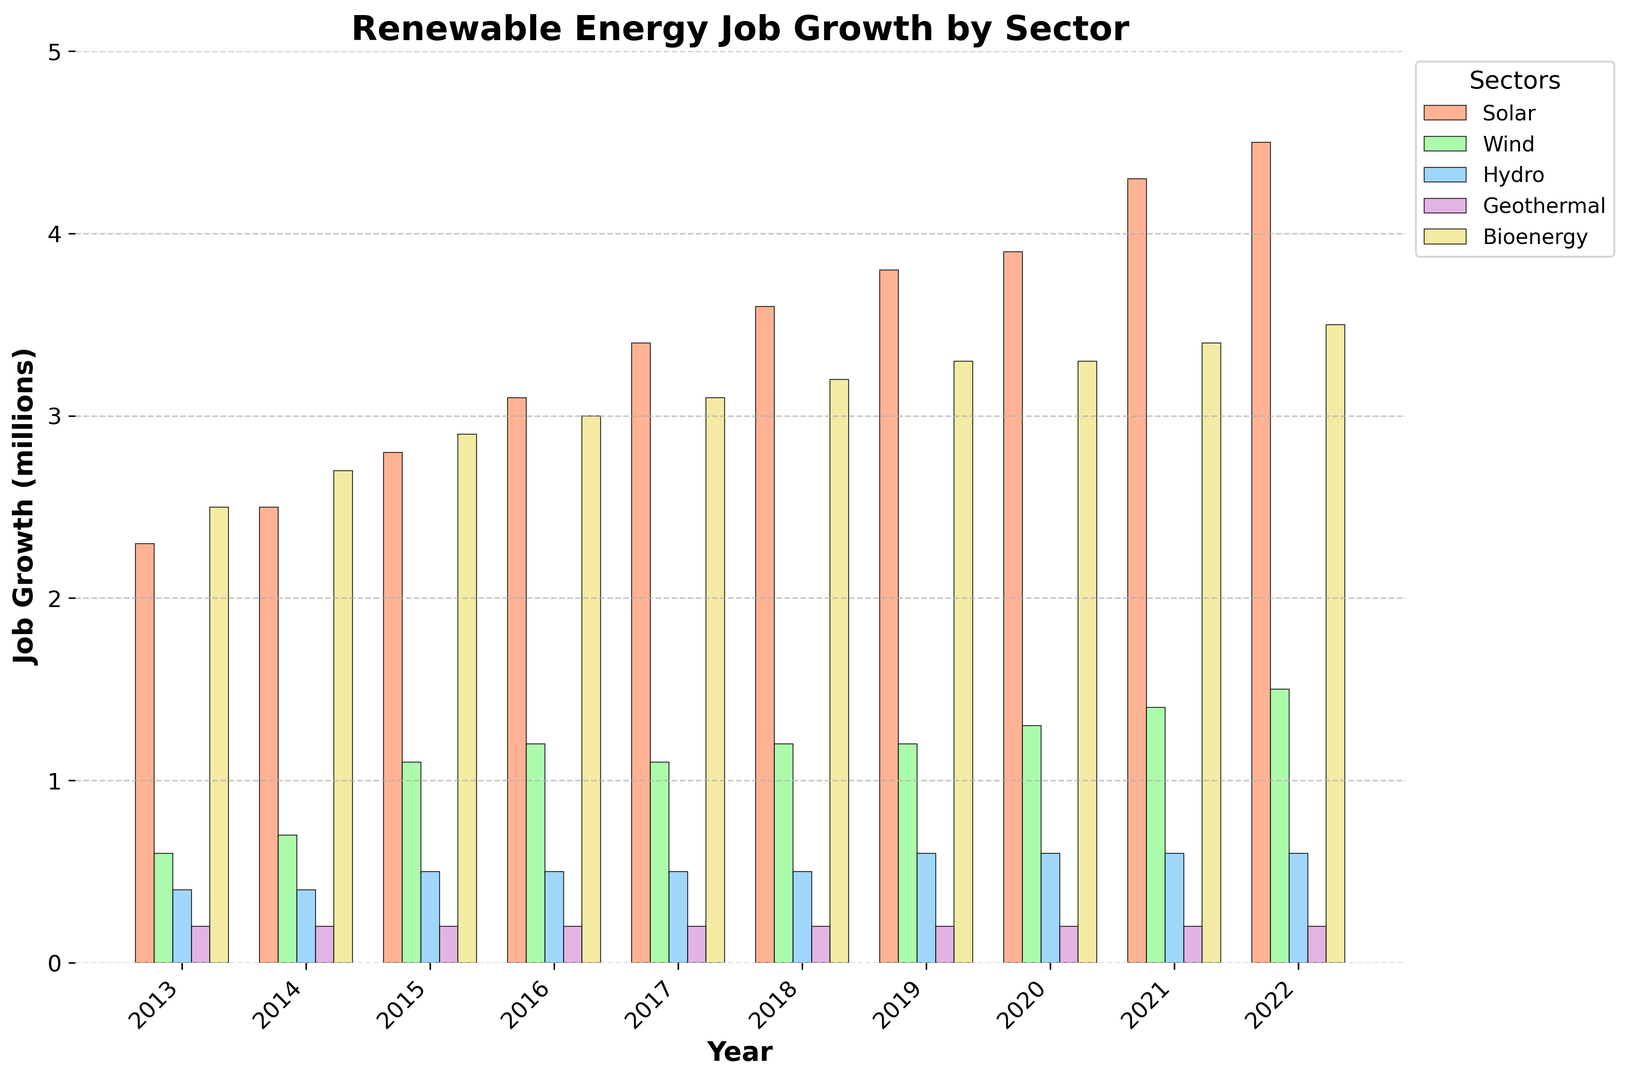What sector shows the highest job growth in 2022? Look at the bar heights for each sector in 2022. The Solar sector has the tallest bar, indicating the highest job growth.
Answer: Solar Which year had the lowest job growth in the Wind sector, and what was it? Among all years, the lowest bar for Wind is in 2013.
Answer: 2013, 0.6 million Between which consecutive years did the Solar sector see the largest increase in job growth? Look for the largest vertical distance between consecutive bars in the Solar sector. The biggest jump is between 2021 and 2022 (from 4.3 million to 4.5 million).
Answer: 2021 and 2022 In 2020, which sector had job growth below 1 million? Check the bar heights for each sector in 2020. Both Hydro and Geothermal sectors have bars below 1 million.
Answer: Hydro and Geothermal Which sector had the most stable job growth over the decade? Identify the sector with the least variation in bar heights over the years. Geothermal shows little to no change over the years.
Answer: Geothermal What is the total job growth in 2019 across all sectors? Sum the 2019 values for all sectors: 3.8 (Solar) + 1.2 (Wind) + 0.6 (Hydro) + 0.2 (Geothermal) + 3.3 (Bioenergy).
Answer: 9.1 million How does Bioenergy's job growth in 2017 compare to 2022? Compare the bar heights for Bioenergy in 2017 and 2022. 2017: 3.1 million; 2022: 3.5 million.
Answer: Higher in 2022 Which sector had no job growth change between 2016 and 2017? Compare the bar heights for 2016 and 2017 for each sector. Hydro and Geothermal both show no change.
Answer: Hydro and Geothermal What is the average job growth for the Wind sector over the decade? Sum the job growth for Wind over the years (0.6 + 0.7 + 1.1 + 1.2 + 1.1 + 1.2 + 1.2 + 1.3 + 1.4 + 1.5) = 12.3 million. Average = 12.3 / 10 years.
Answer: 1.23 million 